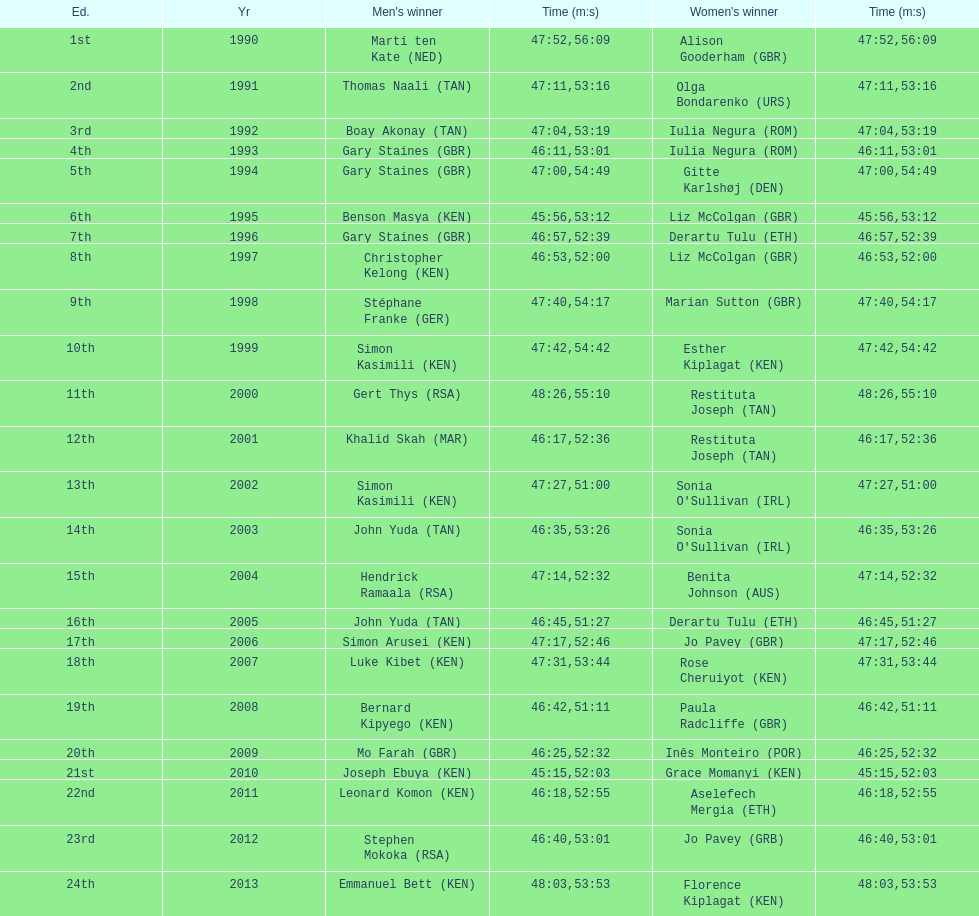Number of men's winners with a finish time under 46:58 12. 